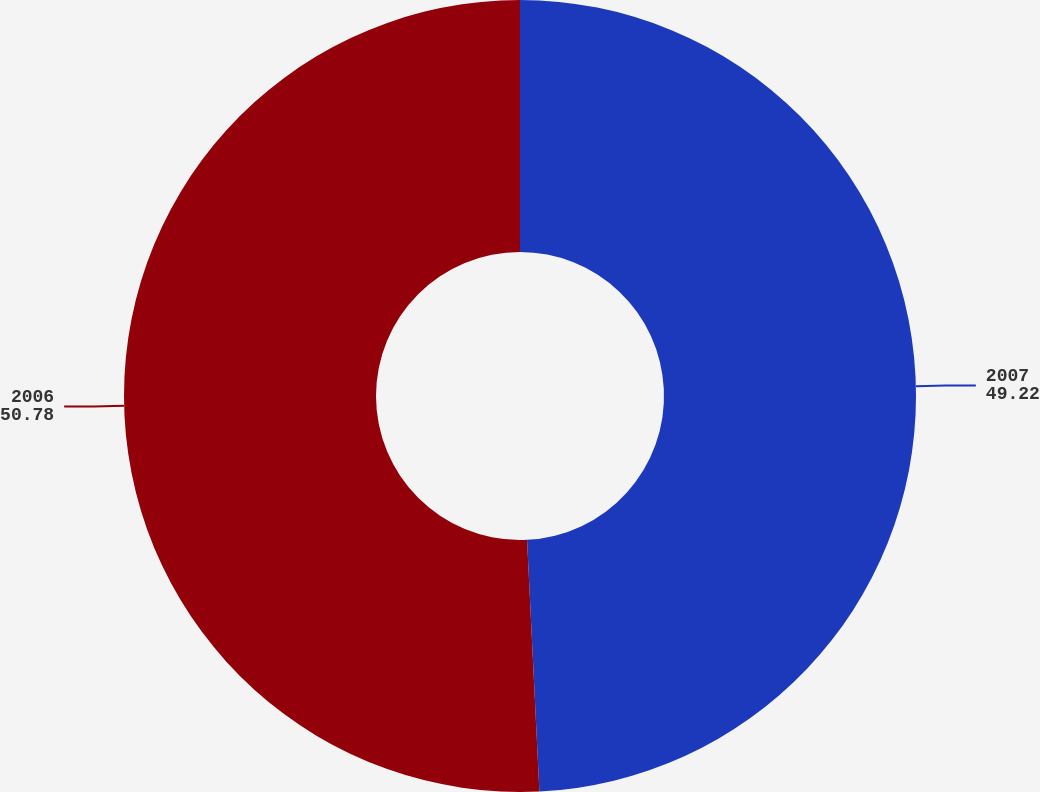Convert chart. <chart><loc_0><loc_0><loc_500><loc_500><pie_chart><fcel>2007<fcel>2006<nl><fcel>49.22%<fcel>50.78%<nl></chart> 